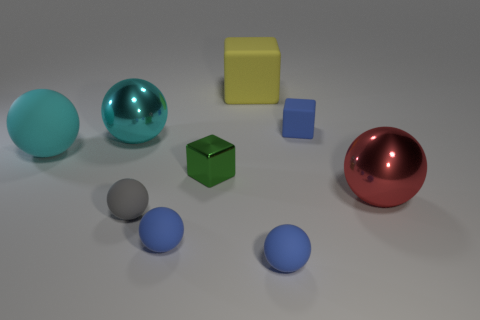Subtract all red spheres. How many spheres are left? 5 Subtract all cyan spheres. How many spheres are left? 4 Subtract all gray balls. Subtract all cyan blocks. How many balls are left? 5 Add 1 blue rubber objects. How many objects exist? 10 Subtract all spheres. How many objects are left? 3 Subtract all shiny blocks. Subtract all blue balls. How many objects are left? 6 Add 4 big red metal objects. How many big red metal objects are left? 5 Add 6 green shiny objects. How many green shiny objects exist? 7 Subtract 0 cyan blocks. How many objects are left? 9 